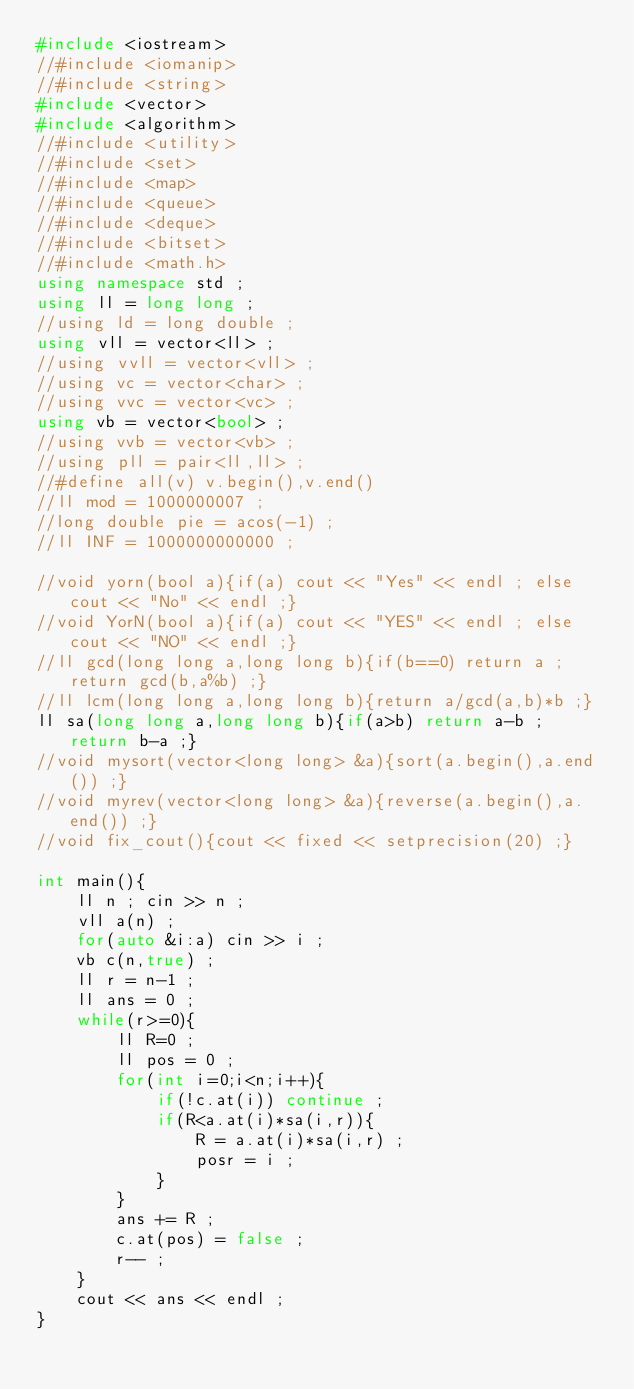<code> <loc_0><loc_0><loc_500><loc_500><_C++_>#include <iostream>
//#include <iomanip>
//#include <string>
#include <vector>
#include <algorithm>
//#include <utility>
//#include <set>
//#include <map>
//#include <queue>
//#include <deque>
//#include <bitset>
//#include <math.h>
using namespace std ;
using ll = long long ;
//using ld = long double ;
using vll = vector<ll> ;
//using vvll = vector<vll> ;
//using vc = vector<char> ;
//using vvc = vector<vc> ;
using vb = vector<bool> ;
//using vvb = vector<vb> ;
//using pll = pair<ll,ll> ;
//#define all(v) v.begin(),v.end()
//ll mod = 1000000007 ;
//long double pie = acos(-1) ;
//ll INF = 1000000000000 ;

//void yorn(bool a){if(a) cout << "Yes" << endl ; else cout << "No" << endl ;}
//void YorN(bool a){if(a) cout << "YES" << endl ; else cout << "NO" << endl ;}
//ll gcd(long long a,long long b){if(b==0) return a ; return gcd(b,a%b) ;}
//ll lcm(long long a,long long b){return a/gcd(a,b)*b ;}
ll sa(long long a,long long b){if(a>b) return a-b ; return b-a ;}
//void mysort(vector<long long> &a){sort(a.begin(),a.end()) ;}
//void myrev(vector<long long> &a){reverse(a.begin(),a.end()) ;}
//void fix_cout(){cout << fixed << setprecision(20) ;}

int main(){
	ll n ; cin >> n ;
	vll a(n) ;
	for(auto &i:a) cin >> i ;
	vb c(n,true) ;
	ll r = n-1 ;
	ll ans = 0 ;
	while(r>=0){
		ll R=0 ;
		ll pos = 0 ;
		for(int i=0;i<n;i++){
			if(!c.at(i)) continue ;
			if(R<a.at(i)*sa(i,r)){
				R = a.at(i)*sa(i,r) ;
				posr = i ;
			}
		}
		ans += R ;
		c.at(pos) = false ;
		r-- ;
	}
	cout << ans << endl ;
}
</code> 